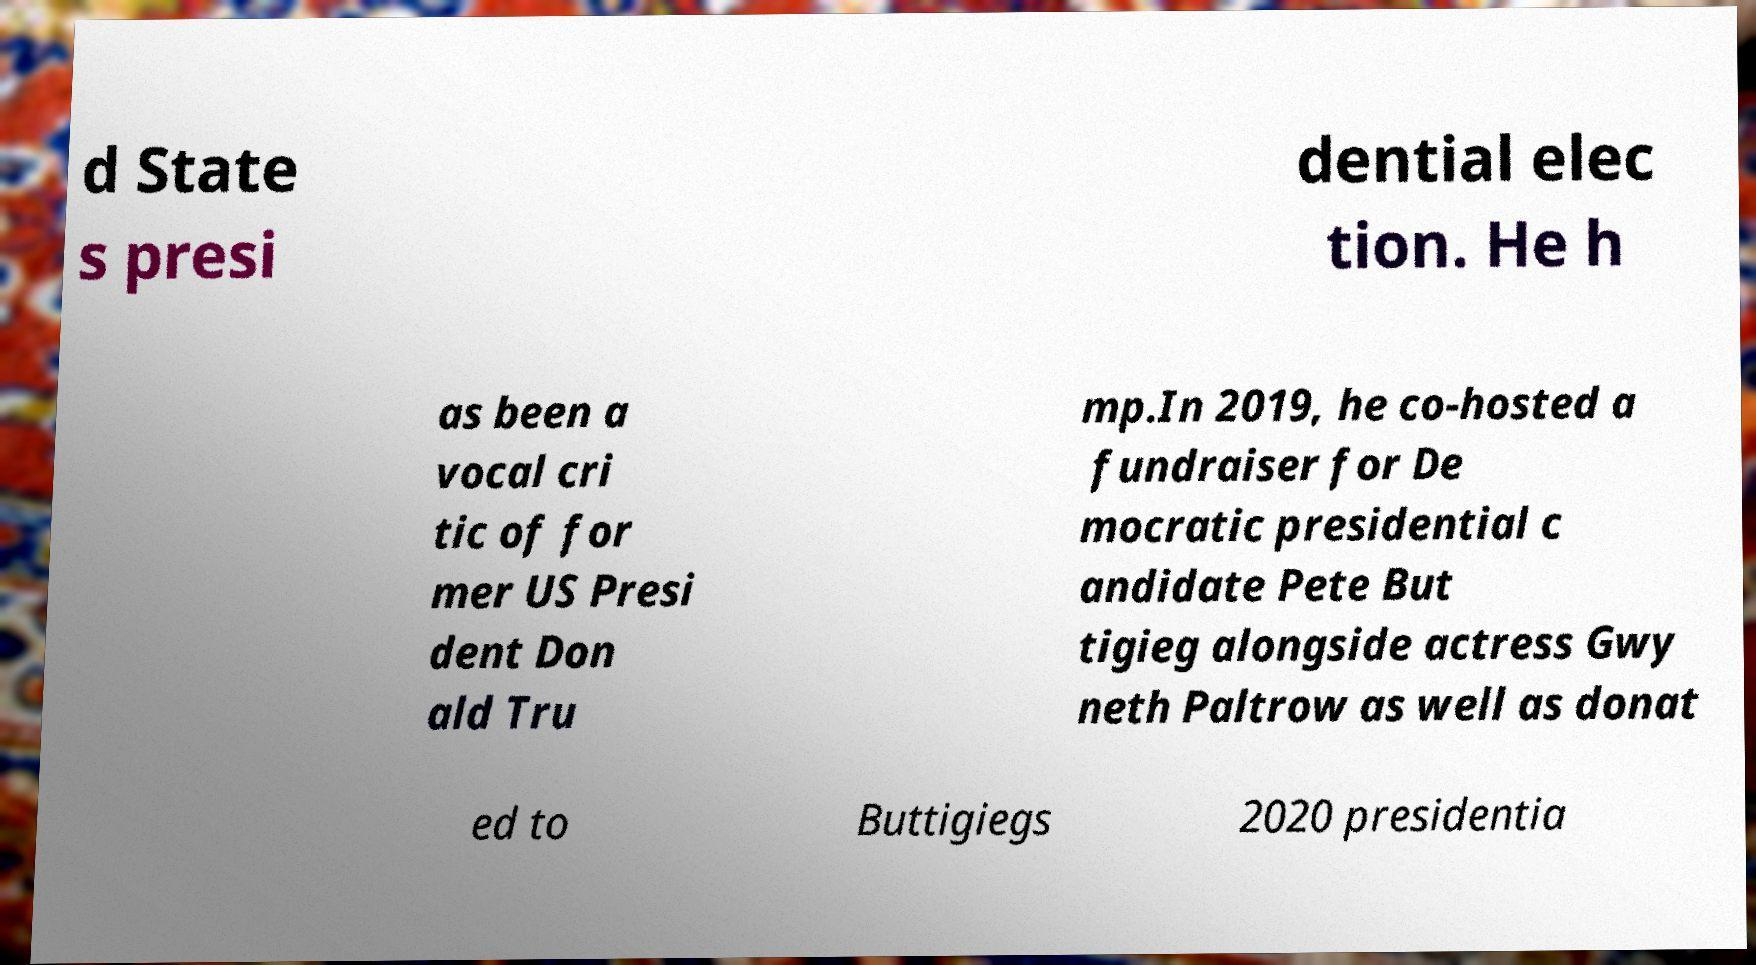What messages or text are displayed in this image? I need them in a readable, typed format. d State s presi dential elec tion. He h as been a vocal cri tic of for mer US Presi dent Don ald Tru mp.In 2019, he co-hosted a fundraiser for De mocratic presidential c andidate Pete But tigieg alongside actress Gwy neth Paltrow as well as donat ed to Buttigiegs 2020 presidentia 